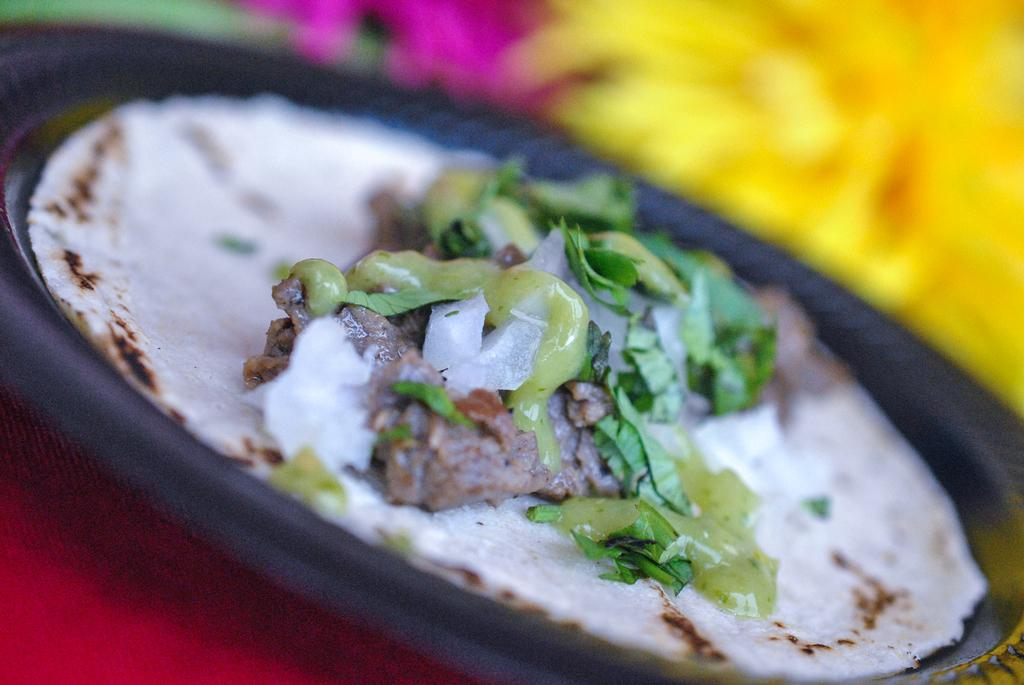What is on the plate that is visible in the image? There is an edible on a plate in the image. What color is the plate? The plate is black. What can be seen in the right top corner of the image? There is a yellow object in the right top corner of the image. How many marbles are present in the image? There is no mention of marbles in the image, so it cannot be determined how many are present. 